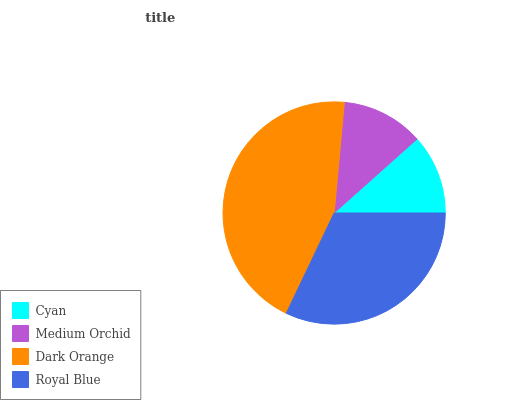Is Cyan the minimum?
Answer yes or no. Yes. Is Dark Orange the maximum?
Answer yes or no. Yes. Is Medium Orchid the minimum?
Answer yes or no. No. Is Medium Orchid the maximum?
Answer yes or no. No. Is Medium Orchid greater than Cyan?
Answer yes or no. Yes. Is Cyan less than Medium Orchid?
Answer yes or no. Yes. Is Cyan greater than Medium Orchid?
Answer yes or no. No. Is Medium Orchid less than Cyan?
Answer yes or no. No. Is Royal Blue the high median?
Answer yes or no. Yes. Is Medium Orchid the low median?
Answer yes or no. Yes. Is Cyan the high median?
Answer yes or no. No. Is Cyan the low median?
Answer yes or no. No. 